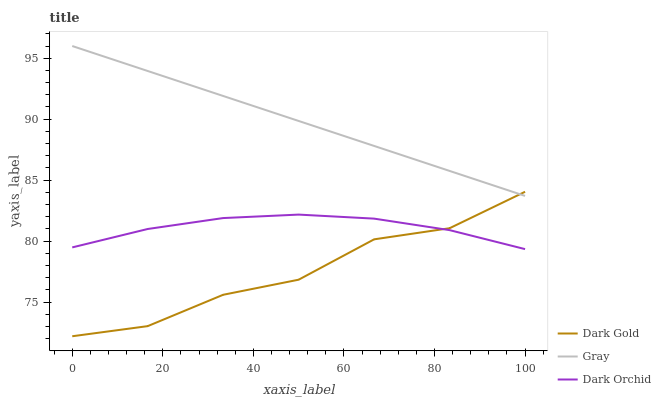Does Dark Gold have the minimum area under the curve?
Answer yes or no. Yes. Does Gray have the maximum area under the curve?
Answer yes or no. Yes. Does Dark Orchid have the minimum area under the curve?
Answer yes or no. No. Does Dark Orchid have the maximum area under the curve?
Answer yes or no. No. Is Gray the smoothest?
Answer yes or no. Yes. Is Dark Gold the roughest?
Answer yes or no. Yes. Is Dark Orchid the smoothest?
Answer yes or no. No. Is Dark Orchid the roughest?
Answer yes or no. No. Does Dark Gold have the lowest value?
Answer yes or no. Yes. Does Dark Orchid have the lowest value?
Answer yes or no. No. Does Gray have the highest value?
Answer yes or no. Yes. Does Dark Gold have the highest value?
Answer yes or no. No. Is Dark Orchid less than Gray?
Answer yes or no. Yes. Is Gray greater than Dark Orchid?
Answer yes or no. Yes. Does Dark Gold intersect Dark Orchid?
Answer yes or no. Yes. Is Dark Gold less than Dark Orchid?
Answer yes or no. No. Is Dark Gold greater than Dark Orchid?
Answer yes or no. No. Does Dark Orchid intersect Gray?
Answer yes or no. No. 